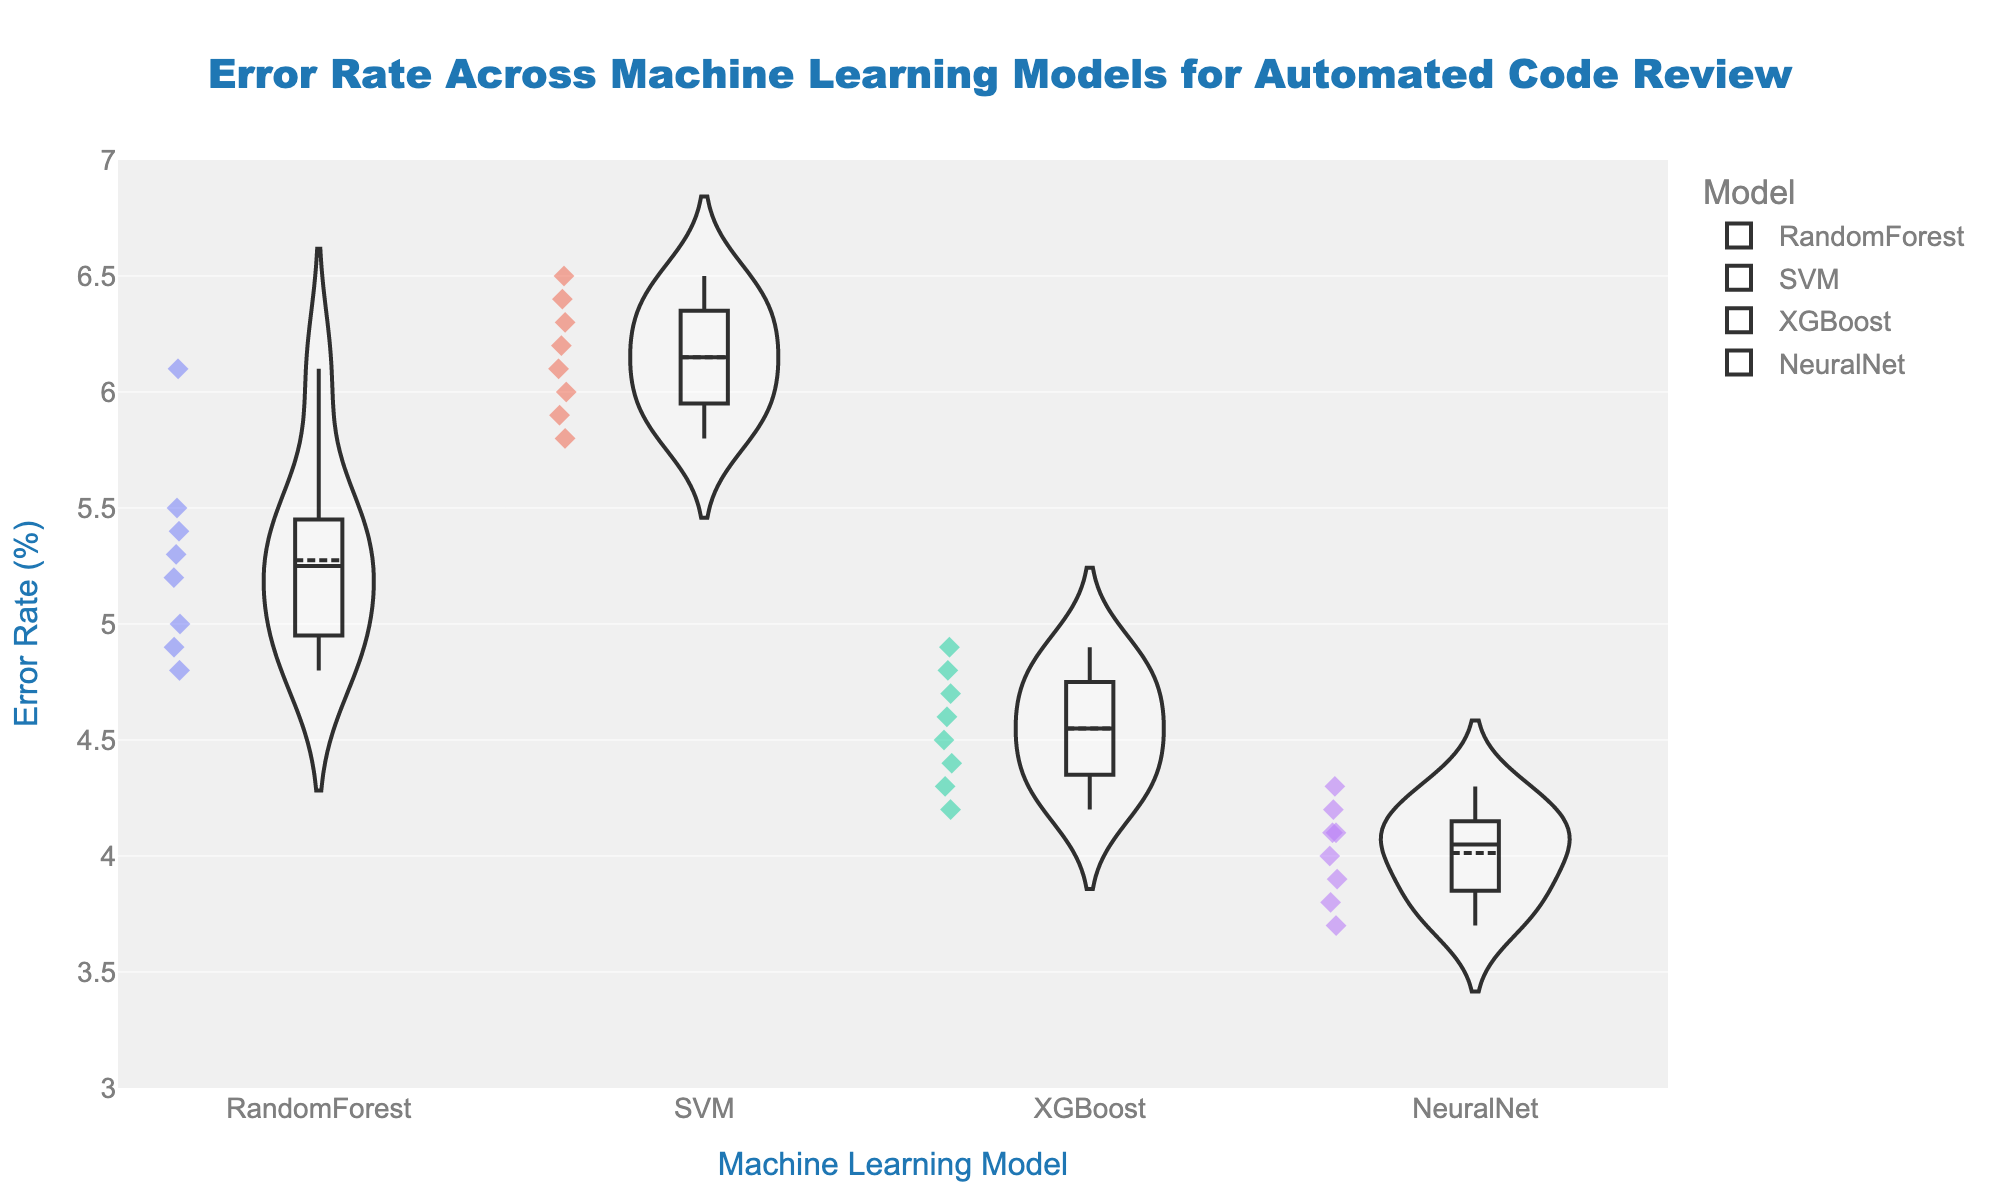what is the title of the plot? The title is located at the top of the plot. The title text is "Error Rate Across Machine Learning Models for Automated Code Review".
Answer: Error Rate Across Machine Learning Models for Automated Code Review What is the range of the y-axis? The y-axis range is shown on the plot's vertical axis. It spans from 3 to 7.
Answer: 3 to 7 Which model has the lowest mean error rate? The mean error rate is indicated by a line within each potential violin plot. The model with the line at the lowest horizontal position on the y-axis has the lowest mean error rate. This would be the NeuralNet model.
Answer: NeuralNet How do the error rates of RandomForest and SVM compare? Examine the positions of the points and the box plots within the violin plots for both the RandomForest and SVM models. The SVM model has a higher distribution of error rates compared to the RandomForest model.
Answer: SVM has higher error rates Which repository has the highest error rate for the SVM model? Look at the jittered points within the violin plot for the SVM model and find the point with the highest vertical position. This repository corresponds to Flask with an error rate of 6.5.
Answer: Flask What's the difference between the highest and lowest error rate for the XGBoost model? Identify the highest and lowest points within the XGBoost violin plot. The highest point is 4.9 and the lowest point is 4.2. The difference is 4.9 - 4.2 = 0.7.
Answer: 0.7 Which model has the most data points and how do you know? Count the number of jittered points within each violin plot. The plot with the highest number of points represents the model with the most data points. All models have an equal number of 8 data points.
Answer: All models have 8 points What is the median error rate for the Django repository across all models? The median is represented by the horizontal line in each box plot within the violin plots. To find the median for Django, identify these lines' positions within the Django repository data points of each model.
Answer: Around 5.0 How does the shape of the NeuralNet violin plot compare to the others? Compare the width and spread of the violin plot for NeuralNet to those of other models. The NeuralNet's plot is narrower, indicating a more consistent error rate close to the mean.
Answer: More narrow and consistent 